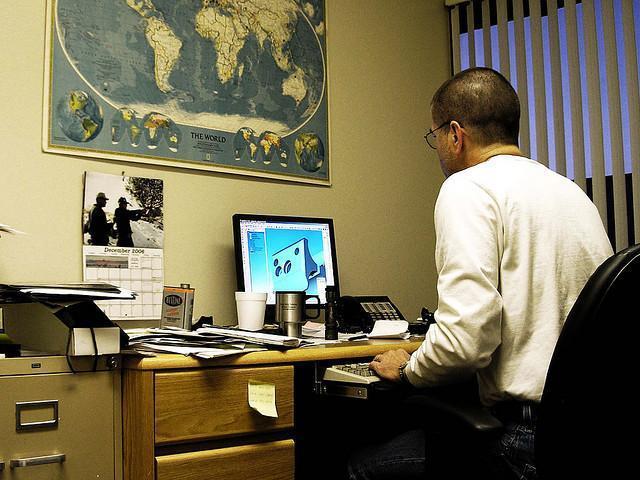Is the given caption "The person is opposite to the tv." fitting for the image?
Answer yes or no. No. 